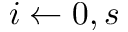<formula> <loc_0><loc_0><loc_500><loc_500>i \leftarrow 0 , s</formula> 